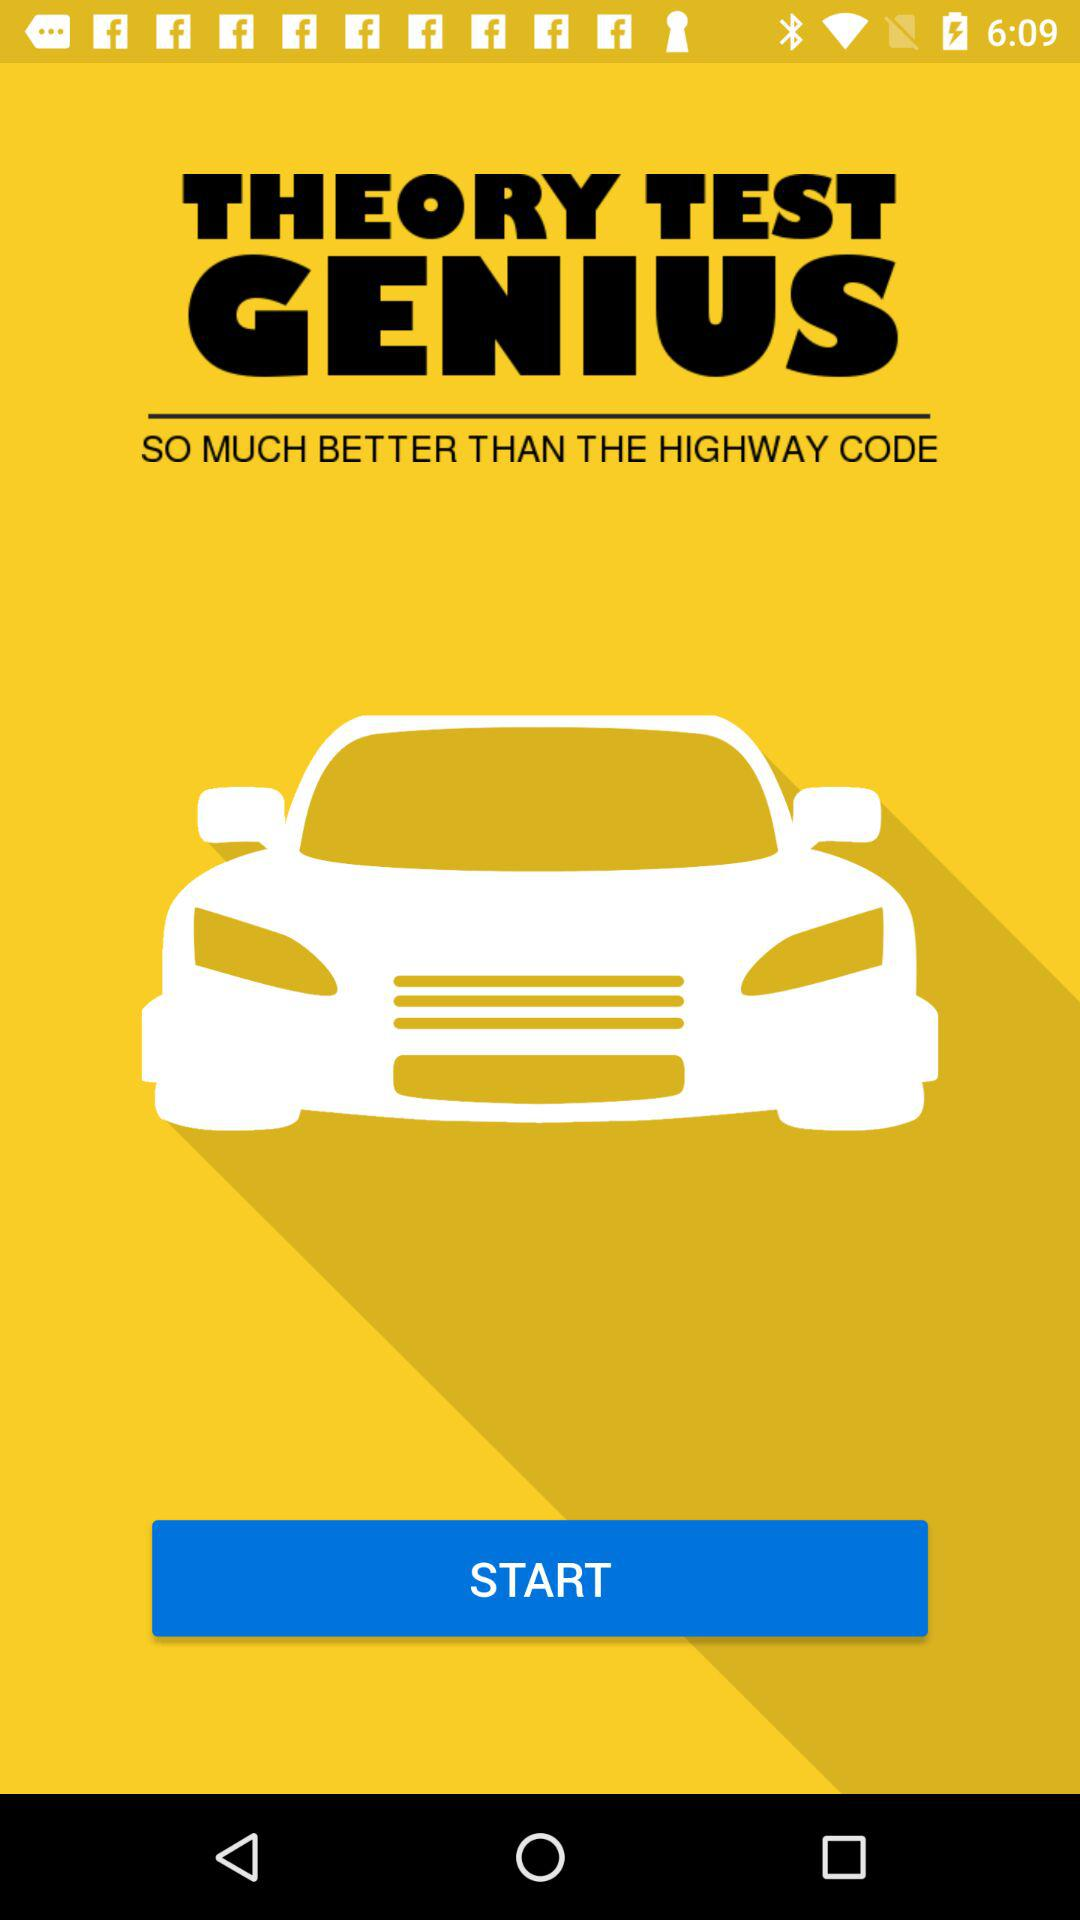What is the application name? The application name is "Theory Test Genius". 